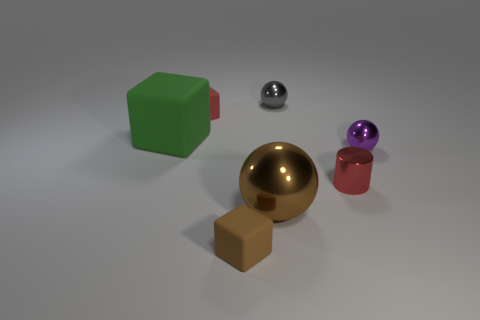Is the number of large brown things behind the big green thing less than the number of green rubber things?
Your answer should be compact. Yes. There is a small metallic object that is behind the tiny block that is behind the small matte object in front of the large rubber object; what shape is it?
Provide a succinct answer. Sphere. Are there more rubber objects than purple rubber cylinders?
Make the answer very short. Yes. What number of other objects are the same material as the big cube?
Give a very brief answer. 2. How many things are tiny gray metallic spheres or metallic objects that are to the right of the large matte cube?
Ensure brevity in your answer.  4. Is the number of gray spheres less than the number of brown things?
Make the answer very short. Yes. The small matte thing in front of the tiny block that is behind the metal sphere on the right side of the gray metallic thing is what color?
Offer a very short reply. Brown. Are the gray sphere and the tiny cylinder made of the same material?
Your response must be concise. Yes. How many red cylinders are on the left side of the red matte block?
Give a very brief answer. 0. What size is the gray object that is the same shape as the large brown metallic object?
Offer a terse response. Small. 